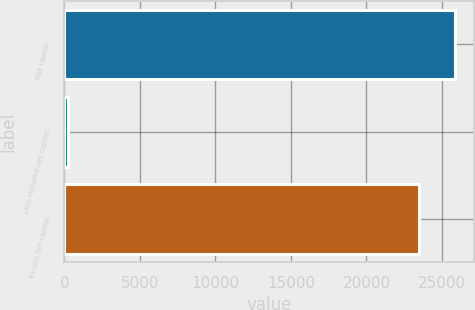Convert chart. <chart><loc_0><loc_0><loc_500><loc_500><bar_chart><fcel>Net capital<fcel>Less required net capital<fcel>Excess net capital<nl><fcel>25847.8<fcel>250<fcel>23498<nl></chart> 